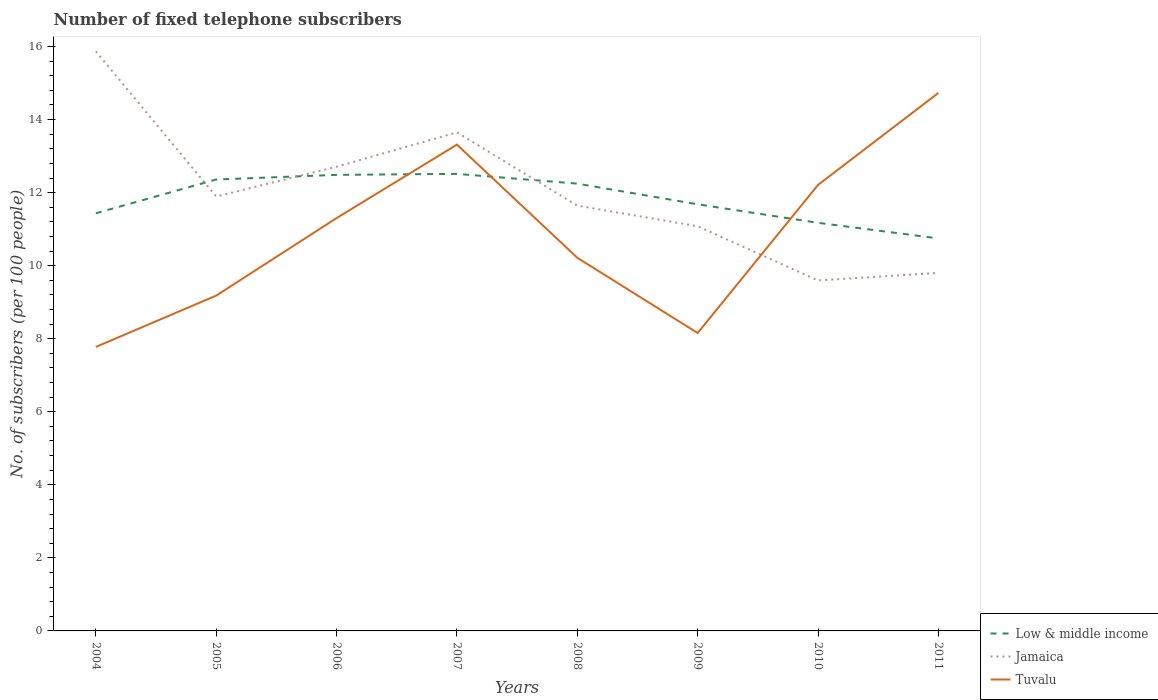Is the number of lines equal to the number of legend labels?
Your answer should be very brief. Yes. Across all years, what is the maximum number of fixed telephone subscribers in Jamaica?
Offer a terse response. 9.6. In which year was the number of fixed telephone subscribers in Jamaica maximum?
Your answer should be compact. 2010. What is the total number of fixed telephone subscribers in Low & middle income in the graph?
Your answer should be compact. 1.5. What is the difference between the highest and the second highest number of fixed telephone subscribers in Tuvalu?
Offer a very short reply. 6.95. How many years are there in the graph?
Provide a short and direct response. 8. What is the difference between two consecutive major ticks on the Y-axis?
Make the answer very short. 2. Are the values on the major ticks of Y-axis written in scientific E-notation?
Your response must be concise. No. Does the graph contain any zero values?
Ensure brevity in your answer.  No. Does the graph contain grids?
Your answer should be very brief. No. How are the legend labels stacked?
Offer a very short reply. Vertical. What is the title of the graph?
Give a very brief answer. Number of fixed telephone subscribers. What is the label or title of the Y-axis?
Offer a terse response. No. of subscribers (per 100 people). What is the No. of subscribers (per 100 people) of Low & middle income in 2004?
Offer a terse response. 11.44. What is the No. of subscribers (per 100 people) in Jamaica in 2004?
Your answer should be compact. 15.87. What is the No. of subscribers (per 100 people) of Tuvalu in 2004?
Your answer should be compact. 7.78. What is the No. of subscribers (per 100 people) of Low & middle income in 2005?
Provide a succinct answer. 12.36. What is the No. of subscribers (per 100 people) in Jamaica in 2005?
Your answer should be very brief. 11.89. What is the No. of subscribers (per 100 people) of Tuvalu in 2005?
Your answer should be very brief. 9.18. What is the No. of subscribers (per 100 people) in Low & middle income in 2006?
Provide a short and direct response. 12.49. What is the No. of subscribers (per 100 people) of Jamaica in 2006?
Keep it short and to the point. 12.71. What is the No. of subscribers (per 100 people) of Tuvalu in 2006?
Your answer should be very brief. 11.3. What is the No. of subscribers (per 100 people) of Low & middle income in 2007?
Make the answer very short. 12.51. What is the No. of subscribers (per 100 people) of Jamaica in 2007?
Provide a short and direct response. 13.65. What is the No. of subscribers (per 100 people) in Tuvalu in 2007?
Provide a succinct answer. 13.31. What is the No. of subscribers (per 100 people) in Low & middle income in 2008?
Give a very brief answer. 12.25. What is the No. of subscribers (per 100 people) in Jamaica in 2008?
Offer a terse response. 11.64. What is the No. of subscribers (per 100 people) of Tuvalu in 2008?
Your response must be concise. 10.22. What is the No. of subscribers (per 100 people) in Low & middle income in 2009?
Your answer should be compact. 11.68. What is the No. of subscribers (per 100 people) of Jamaica in 2009?
Provide a succinct answer. 11.08. What is the No. of subscribers (per 100 people) of Tuvalu in 2009?
Provide a short and direct response. 8.16. What is the No. of subscribers (per 100 people) of Low & middle income in 2010?
Provide a succinct answer. 11.17. What is the No. of subscribers (per 100 people) in Jamaica in 2010?
Ensure brevity in your answer.  9.6. What is the No. of subscribers (per 100 people) of Tuvalu in 2010?
Offer a terse response. 12.21. What is the No. of subscribers (per 100 people) of Low & middle income in 2011?
Provide a short and direct response. 10.75. What is the No. of subscribers (per 100 people) in Jamaica in 2011?
Offer a very short reply. 9.8. What is the No. of subscribers (per 100 people) of Tuvalu in 2011?
Keep it short and to the point. 14.73. Across all years, what is the maximum No. of subscribers (per 100 people) in Low & middle income?
Give a very brief answer. 12.51. Across all years, what is the maximum No. of subscribers (per 100 people) of Jamaica?
Your answer should be very brief. 15.87. Across all years, what is the maximum No. of subscribers (per 100 people) of Tuvalu?
Ensure brevity in your answer.  14.73. Across all years, what is the minimum No. of subscribers (per 100 people) in Low & middle income?
Provide a short and direct response. 10.75. Across all years, what is the minimum No. of subscribers (per 100 people) in Jamaica?
Offer a very short reply. 9.6. Across all years, what is the minimum No. of subscribers (per 100 people) of Tuvalu?
Give a very brief answer. 7.78. What is the total No. of subscribers (per 100 people) of Low & middle income in the graph?
Give a very brief answer. 94.64. What is the total No. of subscribers (per 100 people) in Jamaica in the graph?
Provide a short and direct response. 96.25. What is the total No. of subscribers (per 100 people) of Tuvalu in the graph?
Make the answer very short. 86.89. What is the difference between the No. of subscribers (per 100 people) of Low & middle income in 2004 and that in 2005?
Your answer should be compact. -0.92. What is the difference between the No. of subscribers (per 100 people) of Jamaica in 2004 and that in 2005?
Provide a short and direct response. 3.97. What is the difference between the No. of subscribers (per 100 people) of Tuvalu in 2004 and that in 2005?
Make the answer very short. -1.41. What is the difference between the No. of subscribers (per 100 people) in Low & middle income in 2004 and that in 2006?
Provide a succinct answer. -1.05. What is the difference between the No. of subscribers (per 100 people) in Jamaica in 2004 and that in 2006?
Your answer should be compact. 3.16. What is the difference between the No. of subscribers (per 100 people) of Tuvalu in 2004 and that in 2006?
Make the answer very short. -3.53. What is the difference between the No. of subscribers (per 100 people) in Low & middle income in 2004 and that in 2007?
Ensure brevity in your answer.  -1.08. What is the difference between the No. of subscribers (per 100 people) of Jamaica in 2004 and that in 2007?
Provide a succinct answer. 2.22. What is the difference between the No. of subscribers (per 100 people) of Tuvalu in 2004 and that in 2007?
Your answer should be compact. -5.54. What is the difference between the No. of subscribers (per 100 people) in Low & middle income in 2004 and that in 2008?
Give a very brief answer. -0.81. What is the difference between the No. of subscribers (per 100 people) in Jamaica in 2004 and that in 2008?
Provide a short and direct response. 4.22. What is the difference between the No. of subscribers (per 100 people) in Tuvalu in 2004 and that in 2008?
Offer a terse response. -2.44. What is the difference between the No. of subscribers (per 100 people) in Low & middle income in 2004 and that in 2009?
Offer a very short reply. -0.25. What is the difference between the No. of subscribers (per 100 people) of Jamaica in 2004 and that in 2009?
Ensure brevity in your answer.  4.79. What is the difference between the No. of subscribers (per 100 people) of Tuvalu in 2004 and that in 2009?
Your answer should be compact. -0.38. What is the difference between the No. of subscribers (per 100 people) of Low & middle income in 2004 and that in 2010?
Provide a short and direct response. 0.26. What is the difference between the No. of subscribers (per 100 people) of Jamaica in 2004 and that in 2010?
Offer a very short reply. 6.27. What is the difference between the No. of subscribers (per 100 people) in Tuvalu in 2004 and that in 2010?
Provide a short and direct response. -4.44. What is the difference between the No. of subscribers (per 100 people) in Low & middle income in 2004 and that in 2011?
Your response must be concise. 0.69. What is the difference between the No. of subscribers (per 100 people) of Jamaica in 2004 and that in 2011?
Provide a succinct answer. 6.06. What is the difference between the No. of subscribers (per 100 people) in Tuvalu in 2004 and that in 2011?
Your answer should be compact. -6.95. What is the difference between the No. of subscribers (per 100 people) of Low & middle income in 2005 and that in 2006?
Your answer should be very brief. -0.13. What is the difference between the No. of subscribers (per 100 people) of Jamaica in 2005 and that in 2006?
Your response must be concise. -0.82. What is the difference between the No. of subscribers (per 100 people) in Tuvalu in 2005 and that in 2006?
Ensure brevity in your answer.  -2.12. What is the difference between the No. of subscribers (per 100 people) in Low & middle income in 2005 and that in 2007?
Your response must be concise. -0.15. What is the difference between the No. of subscribers (per 100 people) of Jamaica in 2005 and that in 2007?
Keep it short and to the point. -1.76. What is the difference between the No. of subscribers (per 100 people) of Tuvalu in 2005 and that in 2007?
Ensure brevity in your answer.  -4.13. What is the difference between the No. of subscribers (per 100 people) of Low & middle income in 2005 and that in 2008?
Your answer should be very brief. 0.11. What is the difference between the No. of subscribers (per 100 people) in Jamaica in 2005 and that in 2008?
Your answer should be compact. 0.25. What is the difference between the No. of subscribers (per 100 people) in Tuvalu in 2005 and that in 2008?
Ensure brevity in your answer.  -1.04. What is the difference between the No. of subscribers (per 100 people) of Low & middle income in 2005 and that in 2009?
Ensure brevity in your answer.  0.68. What is the difference between the No. of subscribers (per 100 people) of Jamaica in 2005 and that in 2009?
Ensure brevity in your answer.  0.81. What is the difference between the No. of subscribers (per 100 people) of Tuvalu in 2005 and that in 2009?
Offer a terse response. 1.02. What is the difference between the No. of subscribers (per 100 people) in Low & middle income in 2005 and that in 2010?
Offer a terse response. 1.19. What is the difference between the No. of subscribers (per 100 people) in Jamaica in 2005 and that in 2010?
Make the answer very short. 2.3. What is the difference between the No. of subscribers (per 100 people) of Tuvalu in 2005 and that in 2010?
Make the answer very short. -3.03. What is the difference between the No. of subscribers (per 100 people) in Low & middle income in 2005 and that in 2011?
Provide a short and direct response. 1.61. What is the difference between the No. of subscribers (per 100 people) in Jamaica in 2005 and that in 2011?
Make the answer very short. 2.09. What is the difference between the No. of subscribers (per 100 people) in Tuvalu in 2005 and that in 2011?
Ensure brevity in your answer.  -5.55. What is the difference between the No. of subscribers (per 100 people) in Low & middle income in 2006 and that in 2007?
Your answer should be very brief. -0.03. What is the difference between the No. of subscribers (per 100 people) in Jamaica in 2006 and that in 2007?
Your answer should be very brief. -0.94. What is the difference between the No. of subscribers (per 100 people) of Tuvalu in 2006 and that in 2007?
Your answer should be compact. -2.01. What is the difference between the No. of subscribers (per 100 people) of Low & middle income in 2006 and that in 2008?
Provide a short and direct response. 0.24. What is the difference between the No. of subscribers (per 100 people) of Jamaica in 2006 and that in 2008?
Your answer should be very brief. 1.07. What is the difference between the No. of subscribers (per 100 people) of Tuvalu in 2006 and that in 2008?
Ensure brevity in your answer.  1.09. What is the difference between the No. of subscribers (per 100 people) of Low & middle income in 2006 and that in 2009?
Give a very brief answer. 0.81. What is the difference between the No. of subscribers (per 100 people) of Jamaica in 2006 and that in 2009?
Your response must be concise. 1.63. What is the difference between the No. of subscribers (per 100 people) of Tuvalu in 2006 and that in 2009?
Provide a succinct answer. 3.15. What is the difference between the No. of subscribers (per 100 people) of Low & middle income in 2006 and that in 2010?
Your response must be concise. 1.31. What is the difference between the No. of subscribers (per 100 people) of Jamaica in 2006 and that in 2010?
Your answer should be compact. 3.11. What is the difference between the No. of subscribers (per 100 people) in Tuvalu in 2006 and that in 2010?
Offer a very short reply. -0.91. What is the difference between the No. of subscribers (per 100 people) of Low & middle income in 2006 and that in 2011?
Offer a terse response. 1.74. What is the difference between the No. of subscribers (per 100 people) of Jamaica in 2006 and that in 2011?
Give a very brief answer. 2.91. What is the difference between the No. of subscribers (per 100 people) of Tuvalu in 2006 and that in 2011?
Give a very brief answer. -3.43. What is the difference between the No. of subscribers (per 100 people) in Low & middle income in 2007 and that in 2008?
Ensure brevity in your answer.  0.27. What is the difference between the No. of subscribers (per 100 people) in Jamaica in 2007 and that in 2008?
Your answer should be very brief. 2.01. What is the difference between the No. of subscribers (per 100 people) of Tuvalu in 2007 and that in 2008?
Your answer should be compact. 3.1. What is the difference between the No. of subscribers (per 100 people) in Low & middle income in 2007 and that in 2009?
Offer a terse response. 0.83. What is the difference between the No. of subscribers (per 100 people) of Jamaica in 2007 and that in 2009?
Offer a terse response. 2.57. What is the difference between the No. of subscribers (per 100 people) of Tuvalu in 2007 and that in 2009?
Your answer should be very brief. 5.16. What is the difference between the No. of subscribers (per 100 people) of Low & middle income in 2007 and that in 2010?
Your answer should be very brief. 1.34. What is the difference between the No. of subscribers (per 100 people) of Jamaica in 2007 and that in 2010?
Your answer should be very brief. 4.05. What is the difference between the No. of subscribers (per 100 people) in Tuvalu in 2007 and that in 2010?
Keep it short and to the point. 1.1. What is the difference between the No. of subscribers (per 100 people) of Low & middle income in 2007 and that in 2011?
Provide a succinct answer. 1.77. What is the difference between the No. of subscribers (per 100 people) of Jamaica in 2007 and that in 2011?
Make the answer very short. 3.85. What is the difference between the No. of subscribers (per 100 people) in Tuvalu in 2007 and that in 2011?
Offer a terse response. -1.42. What is the difference between the No. of subscribers (per 100 people) of Low & middle income in 2008 and that in 2009?
Provide a succinct answer. 0.57. What is the difference between the No. of subscribers (per 100 people) in Jamaica in 2008 and that in 2009?
Offer a very short reply. 0.56. What is the difference between the No. of subscribers (per 100 people) of Tuvalu in 2008 and that in 2009?
Offer a very short reply. 2.06. What is the difference between the No. of subscribers (per 100 people) in Low & middle income in 2008 and that in 2010?
Offer a terse response. 1.07. What is the difference between the No. of subscribers (per 100 people) of Jamaica in 2008 and that in 2010?
Keep it short and to the point. 2.05. What is the difference between the No. of subscribers (per 100 people) in Tuvalu in 2008 and that in 2010?
Provide a succinct answer. -1.99. What is the difference between the No. of subscribers (per 100 people) in Low & middle income in 2008 and that in 2011?
Offer a very short reply. 1.5. What is the difference between the No. of subscribers (per 100 people) of Jamaica in 2008 and that in 2011?
Your answer should be very brief. 1.84. What is the difference between the No. of subscribers (per 100 people) of Tuvalu in 2008 and that in 2011?
Your answer should be compact. -4.51. What is the difference between the No. of subscribers (per 100 people) of Low & middle income in 2009 and that in 2010?
Make the answer very short. 0.51. What is the difference between the No. of subscribers (per 100 people) in Jamaica in 2009 and that in 2010?
Keep it short and to the point. 1.48. What is the difference between the No. of subscribers (per 100 people) in Tuvalu in 2009 and that in 2010?
Offer a terse response. -4.05. What is the difference between the No. of subscribers (per 100 people) of Low & middle income in 2009 and that in 2011?
Provide a short and direct response. 0.93. What is the difference between the No. of subscribers (per 100 people) in Jamaica in 2009 and that in 2011?
Provide a succinct answer. 1.28. What is the difference between the No. of subscribers (per 100 people) of Tuvalu in 2009 and that in 2011?
Provide a succinct answer. -6.57. What is the difference between the No. of subscribers (per 100 people) in Low & middle income in 2010 and that in 2011?
Your answer should be compact. 0.43. What is the difference between the No. of subscribers (per 100 people) of Jamaica in 2010 and that in 2011?
Provide a succinct answer. -0.21. What is the difference between the No. of subscribers (per 100 people) of Tuvalu in 2010 and that in 2011?
Offer a very short reply. -2.52. What is the difference between the No. of subscribers (per 100 people) in Low & middle income in 2004 and the No. of subscribers (per 100 people) in Jamaica in 2005?
Keep it short and to the point. -0.46. What is the difference between the No. of subscribers (per 100 people) of Low & middle income in 2004 and the No. of subscribers (per 100 people) of Tuvalu in 2005?
Keep it short and to the point. 2.25. What is the difference between the No. of subscribers (per 100 people) in Jamaica in 2004 and the No. of subscribers (per 100 people) in Tuvalu in 2005?
Offer a terse response. 6.69. What is the difference between the No. of subscribers (per 100 people) in Low & middle income in 2004 and the No. of subscribers (per 100 people) in Jamaica in 2006?
Give a very brief answer. -1.27. What is the difference between the No. of subscribers (per 100 people) of Low & middle income in 2004 and the No. of subscribers (per 100 people) of Tuvalu in 2006?
Provide a succinct answer. 0.13. What is the difference between the No. of subscribers (per 100 people) in Jamaica in 2004 and the No. of subscribers (per 100 people) in Tuvalu in 2006?
Your answer should be very brief. 4.57. What is the difference between the No. of subscribers (per 100 people) of Low & middle income in 2004 and the No. of subscribers (per 100 people) of Jamaica in 2007?
Give a very brief answer. -2.21. What is the difference between the No. of subscribers (per 100 people) of Low & middle income in 2004 and the No. of subscribers (per 100 people) of Tuvalu in 2007?
Offer a very short reply. -1.88. What is the difference between the No. of subscribers (per 100 people) in Jamaica in 2004 and the No. of subscribers (per 100 people) in Tuvalu in 2007?
Provide a short and direct response. 2.55. What is the difference between the No. of subscribers (per 100 people) in Low & middle income in 2004 and the No. of subscribers (per 100 people) in Jamaica in 2008?
Give a very brief answer. -0.21. What is the difference between the No. of subscribers (per 100 people) of Low & middle income in 2004 and the No. of subscribers (per 100 people) of Tuvalu in 2008?
Provide a succinct answer. 1.22. What is the difference between the No. of subscribers (per 100 people) in Jamaica in 2004 and the No. of subscribers (per 100 people) in Tuvalu in 2008?
Offer a terse response. 5.65. What is the difference between the No. of subscribers (per 100 people) of Low & middle income in 2004 and the No. of subscribers (per 100 people) of Jamaica in 2009?
Give a very brief answer. 0.35. What is the difference between the No. of subscribers (per 100 people) in Low & middle income in 2004 and the No. of subscribers (per 100 people) in Tuvalu in 2009?
Your answer should be very brief. 3.28. What is the difference between the No. of subscribers (per 100 people) of Jamaica in 2004 and the No. of subscribers (per 100 people) of Tuvalu in 2009?
Offer a very short reply. 7.71. What is the difference between the No. of subscribers (per 100 people) in Low & middle income in 2004 and the No. of subscribers (per 100 people) in Jamaica in 2010?
Give a very brief answer. 1.84. What is the difference between the No. of subscribers (per 100 people) of Low & middle income in 2004 and the No. of subscribers (per 100 people) of Tuvalu in 2010?
Offer a terse response. -0.78. What is the difference between the No. of subscribers (per 100 people) in Jamaica in 2004 and the No. of subscribers (per 100 people) in Tuvalu in 2010?
Offer a very short reply. 3.66. What is the difference between the No. of subscribers (per 100 people) of Low & middle income in 2004 and the No. of subscribers (per 100 people) of Jamaica in 2011?
Your answer should be very brief. 1.63. What is the difference between the No. of subscribers (per 100 people) of Low & middle income in 2004 and the No. of subscribers (per 100 people) of Tuvalu in 2011?
Provide a succinct answer. -3.29. What is the difference between the No. of subscribers (per 100 people) in Jamaica in 2004 and the No. of subscribers (per 100 people) in Tuvalu in 2011?
Provide a succinct answer. 1.14. What is the difference between the No. of subscribers (per 100 people) in Low & middle income in 2005 and the No. of subscribers (per 100 people) in Jamaica in 2006?
Provide a short and direct response. -0.35. What is the difference between the No. of subscribers (per 100 people) in Low & middle income in 2005 and the No. of subscribers (per 100 people) in Tuvalu in 2006?
Make the answer very short. 1.06. What is the difference between the No. of subscribers (per 100 people) of Jamaica in 2005 and the No. of subscribers (per 100 people) of Tuvalu in 2006?
Provide a succinct answer. 0.59. What is the difference between the No. of subscribers (per 100 people) in Low & middle income in 2005 and the No. of subscribers (per 100 people) in Jamaica in 2007?
Your answer should be very brief. -1.29. What is the difference between the No. of subscribers (per 100 people) of Low & middle income in 2005 and the No. of subscribers (per 100 people) of Tuvalu in 2007?
Your answer should be compact. -0.95. What is the difference between the No. of subscribers (per 100 people) in Jamaica in 2005 and the No. of subscribers (per 100 people) in Tuvalu in 2007?
Provide a short and direct response. -1.42. What is the difference between the No. of subscribers (per 100 people) in Low & middle income in 2005 and the No. of subscribers (per 100 people) in Jamaica in 2008?
Make the answer very short. 0.72. What is the difference between the No. of subscribers (per 100 people) in Low & middle income in 2005 and the No. of subscribers (per 100 people) in Tuvalu in 2008?
Make the answer very short. 2.14. What is the difference between the No. of subscribers (per 100 people) in Jamaica in 2005 and the No. of subscribers (per 100 people) in Tuvalu in 2008?
Make the answer very short. 1.68. What is the difference between the No. of subscribers (per 100 people) of Low & middle income in 2005 and the No. of subscribers (per 100 people) of Jamaica in 2009?
Offer a terse response. 1.28. What is the difference between the No. of subscribers (per 100 people) of Low & middle income in 2005 and the No. of subscribers (per 100 people) of Tuvalu in 2009?
Your answer should be compact. 4.2. What is the difference between the No. of subscribers (per 100 people) of Jamaica in 2005 and the No. of subscribers (per 100 people) of Tuvalu in 2009?
Your answer should be very brief. 3.74. What is the difference between the No. of subscribers (per 100 people) of Low & middle income in 2005 and the No. of subscribers (per 100 people) of Jamaica in 2010?
Your response must be concise. 2.76. What is the difference between the No. of subscribers (per 100 people) in Low & middle income in 2005 and the No. of subscribers (per 100 people) in Tuvalu in 2010?
Your answer should be very brief. 0.15. What is the difference between the No. of subscribers (per 100 people) of Jamaica in 2005 and the No. of subscribers (per 100 people) of Tuvalu in 2010?
Offer a terse response. -0.32. What is the difference between the No. of subscribers (per 100 people) in Low & middle income in 2005 and the No. of subscribers (per 100 people) in Jamaica in 2011?
Provide a succinct answer. 2.56. What is the difference between the No. of subscribers (per 100 people) in Low & middle income in 2005 and the No. of subscribers (per 100 people) in Tuvalu in 2011?
Make the answer very short. -2.37. What is the difference between the No. of subscribers (per 100 people) of Jamaica in 2005 and the No. of subscribers (per 100 people) of Tuvalu in 2011?
Your answer should be compact. -2.84. What is the difference between the No. of subscribers (per 100 people) of Low & middle income in 2006 and the No. of subscribers (per 100 people) of Jamaica in 2007?
Make the answer very short. -1.16. What is the difference between the No. of subscribers (per 100 people) in Low & middle income in 2006 and the No. of subscribers (per 100 people) in Tuvalu in 2007?
Your response must be concise. -0.83. What is the difference between the No. of subscribers (per 100 people) of Jamaica in 2006 and the No. of subscribers (per 100 people) of Tuvalu in 2007?
Provide a succinct answer. -0.6. What is the difference between the No. of subscribers (per 100 people) of Low & middle income in 2006 and the No. of subscribers (per 100 people) of Jamaica in 2008?
Provide a short and direct response. 0.84. What is the difference between the No. of subscribers (per 100 people) of Low & middle income in 2006 and the No. of subscribers (per 100 people) of Tuvalu in 2008?
Your response must be concise. 2.27. What is the difference between the No. of subscribers (per 100 people) in Jamaica in 2006 and the No. of subscribers (per 100 people) in Tuvalu in 2008?
Your response must be concise. 2.49. What is the difference between the No. of subscribers (per 100 people) in Low & middle income in 2006 and the No. of subscribers (per 100 people) in Jamaica in 2009?
Offer a terse response. 1.41. What is the difference between the No. of subscribers (per 100 people) of Low & middle income in 2006 and the No. of subscribers (per 100 people) of Tuvalu in 2009?
Your response must be concise. 4.33. What is the difference between the No. of subscribers (per 100 people) in Jamaica in 2006 and the No. of subscribers (per 100 people) in Tuvalu in 2009?
Provide a succinct answer. 4.55. What is the difference between the No. of subscribers (per 100 people) in Low & middle income in 2006 and the No. of subscribers (per 100 people) in Jamaica in 2010?
Make the answer very short. 2.89. What is the difference between the No. of subscribers (per 100 people) of Low & middle income in 2006 and the No. of subscribers (per 100 people) of Tuvalu in 2010?
Offer a very short reply. 0.28. What is the difference between the No. of subscribers (per 100 people) in Jamaica in 2006 and the No. of subscribers (per 100 people) in Tuvalu in 2010?
Make the answer very short. 0.5. What is the difference between the No. of subscribers (per 100 people) in Low & middle income in 2006 and the No. of subscribers (per 100 people) in Jamaica in 2011?
Ensure brevity in your answer.  2.68. What is the difference between the No. of subscribers (per 100 people) in Low & middle income in 2006 and the No. of subscribers (per 100 people) in Tuvalu in 2011?
Provide a succinct answer. -2.24. What is the difference between the No. of subscribers (per 100 people) of Jamaica in 2006 and the No. of subscribers (per 100 people) of Tuvalu in 2011?
Your response must be concise. -2.02. What is the difference between the No. of subscribers (per 100 people) in Low & middle income in 2007 and the No. of subscribers (per 100 people) in Jamaica in 2008?
Your response must be concise. 0.87. What is the difference between the No. of subscribers (per 100 people) of Low & middle income in 2007 and the No. of subscribers (per 100 people) of Tuvalu in 2008?
Your answer should be compact. 2.3. What is the difference between the No. of subscribers (per 100 people) in Jamaica in 2007 and the No. of subscribers (per 100 people) in Tuvalu in 2008?
Keep it short and to the point. 3.43. What is the difference between the No. of subscribers (per 100 people) in Low & middle income in 2007 and the No. of subscribers (per 100 people) in Jamaica in 2009?
Offer a very short reply. 1.43. What is the difference between the No. of subscribers (per 100 people) in Low & middle income in 2007 and the No. of subscribers (per 100 people) in Tuvalu in 2009?
Give a very brief answer. 4.36. What is the difference between the No. of subscribers (per 100 people) in Jamaica in 2007 and the No. of subscribers (per 100 people) in Tuvalu in 2009?
Provide a succinct answer. 5.49. What is the difference between the No. of subscribers (per 100 people) of Low & middle income in 2007 and the No. of subscribers (per 100 people) of Jamaica in 2010?
Keep it short and to the point. 2.92. What is the difference between the No. of subscribers (per 100 people) in Low & middle income in 2007 and the No. of subscribers (per 100 people) in Tuvalu in 2010?
Your answer should be compact. 0.3. What is the difference between the No. of subscribers (per 100 people) of Jamaica in 2007 and the No. of subscribers (per 100 people) of Tuvalu in 2010?
Offer a very short reply. 1.44. What is the difference between the No. of subscribers (per 100 people) in Low & middle income in 2007 and the No. of subscribers (per 100 people) in Jamaica in 2011?
Provide a short and direct response. 2.71. What is the difference between the No. of subscribers (per 100 people) of Low & middle income in 2007 and the No. of subscribers (per 100 people) of Tuvalu in 2011?
Offer a terse response. -2.22. What is the difference between the No. of subscribers (per 100 people) in Jamaica in 2007 and the No. of subscribers (per 100 people) in Tuvalu in 2011?
Your response must be concise. -1.08. What is the difference between the No. of subscribers (per 100 people) of Low & middle income in 2008 and the No. of subscribers (per 100 people) of Jamaica in 2009?
Provide a short and direct response. 1.17. What is the difference between the No. of subscribers (per 100 people) in Low & middle income in 2008 and the No. of subscribers (per 100 people) in Tuvalu in 2009?
Provide a succinct answer. 4.09. What is the difference between the No. of subscribers (per 100 people) in Jamaica in 2008 and the No. of subscribers (per 100 people) in Tuvalu in 2009?
Ensure brevity in your answer.  3.49. What is the difference between the No. of subscribers (per 100 people) of Low & middle income in 2008 and the No. of subscribers (per 100 people) of Jamaica in 2010?
Your response must be concise. 2.65. What is the difference between the No. of subscribers (per 100 people) in Low & middle income in 2008 and the No. of subscribers (per 100 people) in Tuvalu in 2010?
Your answer should be very brief. 0.04. What is the difference between the No. of subscribers (per 100 people) in Jamaica in 2008 and the No. of subscribers (per 100 people) in Tuvalu in 2010?
Your answer should be very brief. -0.57. What is the difference between the No. of subscribers (per 100 people) of Low & middle income in 2008 and the No. of subscribers (per 100 people) of Jamaica in 2011?
Offer a terse response. 2.44. What is the difference between the No. of subscribers (per 100 people) in Low & middle income in 2008 and the No. of subscribers (per 100 people) in Tuvalu in 2011?
Make the answer very short. -2.48. What is the difference between the No. of subscribers (per 100 people) of Jamaica in 2008 and the No. of subscribers (per 100 people) of Tuvalu in 2011?
Offer a terse response. -3.09. What is the difference between the No. of subscribers (per 100 people) in Low & middle income in 2009 and the No. of subscribers (per 100 people) in Jamaica in 2010?
Your response must be concise. 2.09. What is the difference between the No. of subscribers (per 100 people) of Low & middle income in 2009 and the No. of subscribers (per 100 people) of Tuvalu in 2010?
Your answer should be compact. -0.53. What is the difference between the No. of subscribers (per 100 people) of Jamaica in 2009 and the No. of subscribers (per 100 people) of Tuvalu in 2010?
Ensure brevity in your answer.  -1.13. What is the difference between the No. of subscribers (per 100 people) of Low & middle income in 2009 and the No. of subscribers (per 100 people) of Jamaica in 2011?
Offer a terse response. 1.88. What is the difference between the No. of subscribers (per 100 people) of Low & middle income in 2009 and the No. of subscribers (per 100 people) of Tuvalu in 2011?
Your answer should be very brief. -3.05. What is the difference between the No. of subscribers (per 100 people) of Jamaica in 2009 and the No. of subscribers (per 100 people) of Tuvalu in 2011?
Your answer should be very brief. -3.65. What is the difference between the No. of subscribers (per 100 people) of Low & middle income in 2010 and the No. of subscribers (per 100 people) of Jamaica in 2011?
Make the answer very short. 1.37. What is the difference between the No. of subscribers (per 100 people) in Low & middle income in 2010 and the No. of subscribers (per 100 people) in Tuvalu in 2011?
Provide a short and direct response. -3.56. What is the difference between the No. of subscribers (per 100 people) of Jamaica in 2010 and the No. of subscribers (per 100 people) of Tuvalu in 2011?
Ensure brevity in your answer.  -5.13. What is the average No. of subscribers (per 100 people) in Low & middle income per year?
Ensure brevity in your answer.  11.83. What is the average No. of subscribers (per 100 people) in Jamaica per year?
Provide a succinct answer. 12.03. What is the average No. of subscribers (per 100 people) in Tuvalu per year?
Give a very brief answer. 10.86. In the year 2004, what is the difference between the No. of subscribers (per 100 people) in Low & middle income and No. of subscribers (per 100 people) in Jamaica?
Your answer should be very brief. -4.43. In the year 2004, what is the difference between the No. of subscribers (per 100 people) of Low & middle income and No. of subscribers (per 100 people) of Tuvalu?
Your response must be concise. 3.66. In the year 2004, what is the difference between the No. of subscribers (per 100 people) in Jamaica and No. of subscribers (per 100 people) in Tuvalu?
Give a very brief answer. 8.09. In the year 2005, what is the difference between the No. of subscribers (per 100 people) in Low & middle income and No. of subscribers (per 100 people) in Jamaica?
Offer a terse response. 0.47. In the year 2005, what is the difference between the No. of subscribers (per 100 people) of Low & middle income and No. of subscribers (per 100 people) of Tuvalu?
Provide a succinct answer. 3.18. In the year 2005, what is the difference between the No. of subscribers (per 100 people) of Jamaica and No. of subscribers (per 100 people) of Tuvalu?
Give a very brief answer. 2.71. In the year 2006, what is the difference between the No. of subscribers (per 100 people) in Low & middle income and No. of subscribers (per 100 people) in Jamaica?
Give a very brief answer. -0.22. In the year 2006, what is the difference between the No. of subscribers (per 100 people) in Low & middle income and No. of subscribers (per 100 people) in Tuvalu?
Your answer should be very brief. 1.18. In the year 2006, what is the difference between the No. of subscribers (per 100 people) of Jamaica and No. of subscribers (per 100 people) of Tuvalu?
Ensure brevity in your answer.  1.41. In the year 2007, what is the difference between the No. of subscribers (per 100 people) of Low & middle income and No. of subscribers (per 100 people) of Jamaica?
Ensure brevity in your answer.  -1.14. In the year 2007, what is the difference between the No. of subscribers (per 100 people) in Low & middle income and No. of subscribers (per 100 people) in Tuvalu?
Give a very brief answer. -0.8. In the year 2007, what is the difference between the No. of subscribers (per 100 people) of Jamaica and No. of subscribers (per 100 people) of Tuvalu?
Your answer should be very brief. 0.34. In the year 2008, what is the difference between the No. of subscribers (per 100 people) of Low & middle income and No. of subscribers (per 100 people) of Jamaica?
Offer a very short reply. 0.6. In the year 2008, what is the difference between the No. of subscribers (per 100 people) of Low & middle income and No. of subscribers (per 100 people) of Tuvalu?
Offer a very short reply. 2.03. In the year 2008, what is the difference between the No. of subscribers (per 100 people) in Jamaica and No. of subscribers (per 100 people) in Tuvalu?
Your answer should be very brief. 1.43. In the year 2009, what is the difference between the No. of subscribers (per 100 people) of Low & middle income and No. of subscribers (per 100 people) of Jamaica?
Make the answer very short. 0.6. In the year 2009, what is the difference between the No. of subscribers (per 100 people) of Low & middle income and No. of subscribers (per 100 people) of Tuvalu?
Provide a short and direct response. 3.52. In the year 2009, what is the difference between the No. of subscribers (per 100 people) of Jamaica and No. of subscribers (per 100 people) of Tuvalu?
Your answer should be compact. 2.92. In the year 2010, what is the difference between the No. of subscribers (per 100 people) in Low & middle income and No. of subscribers (per 100 people) in Jamaica?
Give a very brief answer. 1.58. In the year 2010, what is the difference between the No. of subscribers (per 100 people) of Low & middle income and No. of subscribers (per 100 people) of Tuvalu?
Ensure brevity in your answer.  -1.04. In the year 2010, what is the difference between the No. of subscribers (per 100 people) in Jamaica and No. of subscribers (per 100 people) in Tuvalu?
Ensure brevity in your answer.  -2.62. In the year 2011, what is the difference between the No. of subscribers (per 100 people) of Low & middle income and No. of subscribers (per 100 people) of Jamaica?
Give a very brief answer. 0.94. In the year 2011, what is the difference between the No. of subscribers (per 100 people) of Low & middle income and No. of subscribers (per 100 people) of Tuvalu?
Make the answer very short. -3.98. In the year 2011, what is the difference between the No. of subscribers (per 100 people) of Jamaica and No. of subscribers (per 100 people) of Tuvalu?
Offer a terse response. -4.93. What is the ratio of the No. of subscribers (per 100 people) in Low & middle income in 2004 to that in 2005?
Provide a succinct answer. 0.93. What is the ratio of the No. of subscribers (per 100 people) in Jamaica in 2004 to that in 2005?
Offer a very short reply. 1.33. What is the ratio of the No. of subscribers (per 100 people) of Tuvalu in 2004 to that in 2005?
Offer a terse response. 0.85. What is the ratio of the No. of subscribers (per 100 people) of Low & middle income in 2004 to that in 2006?
Your answer should be very brief. 0.92. What is the ratio of the No. of subscribers (per 100 people) of Jamaica in 2004 to that in 2006?
Provide a short and direct response. 1.25. What is the ratio of the No. of subscribers (per 100 people) in Tuvalu in 2004 to that in 2006?
Provide a short and direct response. 0.69. What is the ratio of the No. of subscribers (per 100 people) of Low & middle income in 2004 to that in 2007?
Ensure brevity in your answer.  0.91. What is the ratio of the No. of subscribers (per 100 people) of Jamaica in 2004 to that in 2007?
Ensure brevity in your answer.  1.16. What is the ratio of the No. of subscribers (per 100 people) in Tuvalu in 2004 to that in 2007?
Offer a terse response. 0.58. What is the ratio of the No. of subscribers (per 100 people) in Low & middle income in 2004 to that in 2008?
Provide a short and direct response. 0.93. What is the ratio of the No. of subscribers (per 100 people) of Jamaica in 2004 to that in 2008?
Give a very brief answer. 1.36. What is the ratio of the No. of subscribers (per 100 people) of Tuvalu in 2004 to that in 2008?
Your response must be concise. 0.76. What is the ratio of the No. of subscribers (per 100 people) in Low & middle income in 2004 to that in 2009?
Provide a succinct answer. 0.98. What is the ratio of the No. of subscribers (per 100 people) of Jamaica in 2004 to that in 2009?
Your response must be concise. 1.43. What is the ratio of the No. of subscribers (per 100 people) in Tuvalu in 2004 to that in 2009?
Ensure brevity in your answer.  0.95. What is the ratio of the No. of subscribers (per 100 people) of Low & middle income in 2004 to that in 2010?
Offer a very short reply. 1.02. What is the ratio of the No. of subscribers (per 100 people) of Jamaica in 2004 to that in 2010?
Offer a very short reply. 1.65. What is the ratio of the No. of subscribers (per 100 people) of Tuvalu in 2004 to that in 2010?
Provide a succinct answer. 0.64. What is the ratio of the No. of subscribers (per 100 people) in Low & middle income in 2004 to that in 2011?
Provide a short and direct response. 1.06. What is the ratio of the No. of subscribers (per 100 people) of Jamaica in 2004 to that in 2011?
Give a very brief answer. 1.62. What is the ratio of the No. of subscribers (per 100 people) of Tuvalu in 2004 to that in 2011?
Provide a short and direct response. 0.53. What is the ratio of the No. of subscribers (per 100 people) in Jamaica in 2005 to that in 2006?
Your answer should be very brief. 0.94. What is the ratio of the No. of subscribers (per 100 people) in Tuvalu in 2005 to that in 2006?
Provide a short and direct response. 0.81. What is the ratio of the No. of subscribers (per 100 people) of Low & middle income in 2005 to that in 2007?
Your response must be concise. 0.99. What is the ratio of the No. of subscribers (per 100 people) of Jamaica in 2005 to that in 2007?
Make the answer very short. 0.87. What is the ratio of the No. of subscribers (per 100 people) of Tuvalu in 2005 to that in 2007?
Make the answer very short. 0.69. What is the ratio of the No. of subscribers (per 100 people) of Low & middle income in 2005 to that in 2008?
Ensure brevity in your answer.  1.01. What is the ratio of the No. of subscribers (per 100 people) in Jamaica in 2005 to that in 2008?
Ensure brevity in your answer.  1.02. What is the ratio of the No. of subscribers (per 100 people) in Tuvalu in 2005 to that in 2008?
Provide a short and direct response. 0.9. What is the ratio of the No. of subscribers (per 100 people) in Low & middle income in 2005 to that in 2009?
Offer a terse response. 1.06. What is the ratio of the No. of subscribers (per 100 people) in Jamaica in 2005 to that in 2009?
Make the answer very short. 1.07. What is the ratio of the No. of subscribers (per 100 people) in Tuvalu in 2005 to that in 2009?
Offer a terse response. 1.13. What is the ratio of the No. of subscribers (per 100 people) of Low & middle income in 2005 to that in 2010?
Provide a succinct answer. 1.11. What is the ratio of the No. of subscribers (per 100 people) of Jamaica in 2005 to that in 2010?
Offer a very short reply. 1.24. What is the ratio of the No. of subscribers (per 100 people) in Tuvalu in 2005 to that in 2010?
Offer a terse response. 0.75. What is the ratio of the No. of subscribers (per 100 people) in Low & middle income in 2005 to that in 2011?
Keep it short and to the point. 1.15. What is the ratio of the No. of subscribers (per 100 people) of Jamaica in 2005 to that in 2011?
Offer a terse response. 1.21. What is the ratio of the No. of subscribers (per 100 people) in Tuvalu in 2005 to that in 2011?
Provide a succinct answer. 0.62. What is the ratio of the No. of subscribers (per 100 people) of Jamaica in 2006 to that in 2007?
Your response must be concise. 0.93. What is the ratio of the No. of subscribers (per 100 people) in Tuvalu in 2006 to that in 2007?
Your answer should be compact. 0.85. What is the ratio of the No. of subscribers (per 100 people) of Low & middle income in 2006 to that in 2008?
Your answer should be very brief. 1.02. What is the ratio of the No. of subscribers (per 100 people) in Jamaica in 2006 to that in 2008?
Your answer should be compact. 1.09. What is the ratio of the No. of subscribers (per 100 people) in Tuvalu in 2006 to that in 2008?
Give a very brief answer. 1.11. What is the ratio of the No. of subscribers (per 100 people) of Low & middle income in 2006 to that in 2009?
Make the answer very short. 1.07. What is the ratio of the No. of subscribers (per 100 people) in Jamaica in 2006 to that in 2009?
Provide a succinct answer. 1.15. What is the ratio of the No. of subscribers (per 100 people) of Tuvalu in 2006 to that in 2009?
Your answer should be very brief. 1.39. What is the ratio of the No. of subscribers (per 100 people) of Low & middle income in 2006 to that in 2010?
Your response must be concise. 1.12. What is the ratio of the No. of subscribers (per 100 people) of Jamaica in 2006 to that in 2010?
Your response must be concise. 1.32. What is the ratio of the No. of subscribers (per 100 people) in Tuvalu in 2006 to that in 2010?
Keep it short and to the point. 0.93. What is the ratio of the No. of subscribers (per 100 people) of Low & middle income in 2006 to that in 2011?
Make the answer very short. 1.16. What is the ratio of the No. of subscribers (per 100 people) in Jamaica in 2006 to that in 2011?
Ensure brevity in your answer.  1.3. What is the ratio of the No. of subscribers (per 100 people) of Tuvalu in 2006 to that in 2011?
Provide a succinct answer. 0.77. What is the ratio of the No. of subscribers (per 100 people) of Low & middle income in 2007 to that in 2008?
Provide a succinct answer. 1.02. What is the ratio of the No. of subscribers (per 100 people) in Jamaica in 2007 to that in 2008?
Offer a very short reply. 1.17. What is the ratio of the No. of subscribers (per 100 people) of Tuvalu in 2007 to that in 2008?
Provide a short and direct response. 1.3. What is the ratio of the No. of subscribers (per 100 people) of Low & middle income in 2007 to that in 2009?
Provide a succinct answer. 1.07. What is the ratio of the No. of subscribers (per 100 people) in Jamaica in 2007 to that in 2009?
Your answer should be very brief. 1.23. What is the ratio of the No. of subscribers (per 100 people) in Tuvalu in 2007 to that in 2009?
Your answer should be compact. 1.63. What is the ratio of the No. of subscribers (per 100 people) of Low & middle income in 2007 to that in 2010?
Your response must be concise. 1.12. What is the ratio of the No. of subscribers (per 100 people) in Jamaica in 2007 to that in 2010?
Offer a very short reply. 1.42. What is the ratio of the No. of subscribers (per 100 people) in Tuvalu in 2007 to that in 2010?
Offer a very short reply. 1.09. What is the ratio of the No. of subscribers (per 100 people) in Low & middle income in 2007 to that in 2011?
Keep it short and to the point. 1.16. What is the ratio of the No. of subscribers (per 100 people) in Jamaica in 2007 to that in 2011?
Make the answer very short. 1.39. What is the ratio of the No. of subscribers (per 100 people) of Tuvalu in 2007 to that in 2011?
Ensure brevity in your answer.  0.9. What is the ratio of the No. of subscribers (per 100 people) of Low & middle income in 2008 to that in 2009?
Make the answer very short. 1.05. What is the ratio of the No. of subscribers (per 100 people) of Jamaica in 2008 to that in 2009?
Offer a very short reply. 1.05. What is the ratio of the No. of subscribers (per 100 people) of Tuvalu in 2008 to that in 2009?
Your answer should be compact. 1.25. What is the ratio of the No. of subscribers (per 100 people) in Low & middle income in 2008 to that in 2010?
Your answer should be compact. 1.1. What is the ratio of the No. of subscribers (per 100 people) in Jamaica in 2008 to that in 2010?
Your response must be concise. 1.21. What is the ratio of the No. of subscribers (per 100 people) in Tuvalu in 2008 to that in 2010?
Give a very brief answer. 0.84. What is the ratio of the No. of subscribers (per 100 people) in Low & middle income in 2008 to that in 2011?
Offer a very short reply. 1.14. What is the ratio of the No. of subscribers (per 100 people) in Jamaica in 2008 to that in 2011?
Make the answer very short. 1.19. What is the ratio of the No. of subscribers (per 100 people) of Tuvalu in 2008 to that in 2011?
Give a very brief answer. 0.69. What is the ratio of the No. of subscribers (per 100 people) of Low & middle income in 2009 to that in 2010?
Offer a terse response. 1.05. What is the ratio of the No. of subscribers (per 100 people) in Jamaica in 2009 to that in 2010?
Your answer should be compact. 1.15. What is the ratio of the No. of subscribers (per 100 people) of Tuvalu in 2009 to that in 2010?
Provide a short and direct response. 0.67. What is the ratio of the No. of subscribers (per 100 people) in Low & middle income in 2009 to that in 2011?
Give a very brief answer. 1.09. What is the ratio of the No. of subscribers (per 100 people) in Jamaica in 2009 to that in 2011?
Keep it short and to the point. 1.13. What is the ratio of the No. of subscribers (per 100 people) of Tuvalu in 2009 to that in 2011?
Offer a terse response. 0.55. What is the ratio of the No. of subscribers (per 100 people) in Low & middle income in 2010 to that in 2011?
Keep it short and to the point. 1.04. What is the ratio of the No. of subscribers (per 100 people) in Jamaica in 2010 to that in 2011?
Keep it short and to the point. 0.98. What is the ratio of the No. of subscribers (per 100 people) in Tuvalu in 2010 to that in 2011?
Your answer should be very brief. 0.83. What is the difference between the highest and the second highest No. of subscribers (per 100 people) of Low & middle income?
Offer a very short reply. 0.03. What is the difference between the highest and the second highest No. of subscribers (per 100 people) in Jamaica?
Your answer should be very brief. 2.22. What is the difference between the highest and the second highest No. of subscribers (per 100 people) in Tuvalu?
Make the answer very short. 1.42. What is the difference between the highest and the lowest No. of subscribers (per 100 people) of Low & middle income?
Provide a short and direct response. 1.77. What is the difference between the highest and the lowest No. of subscribers (per 100 people) of Jamaica?
Your answer should be very brief. 6.27. What is the difference between the highest and the lowest No. of subscribers (per 100 people) in Tuvalu?
Offer a terse response. 6.95. 